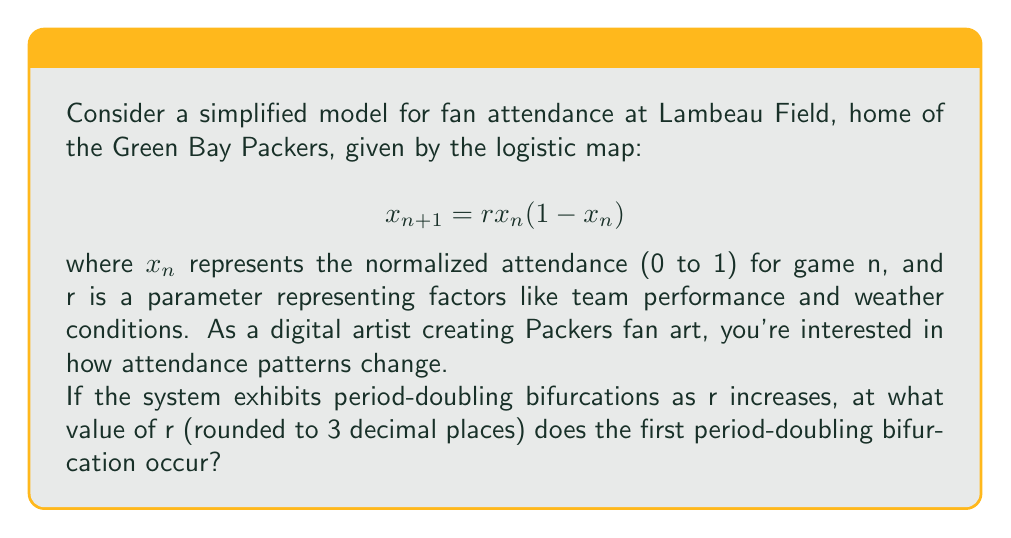What is the answer to this math problem? To find the first period-doubling bifurcation in the logistic map, we need to follow these steps:

1) In a period-1 regime, the system has a fixed point $x^*$ where $x^* = rx^*(1-x^*)$.

2) Solving this equation:
   $$x^* = rx^*(1-x^*)$$
   $$x^* = rx^* - rx^{*2}$$
   $$rx^{*2} - (r-1)x^* = 0$$
   $$x^*(rx^* - (r-1)) = 0$$

   The non-zero solution is $x^* = 1 - \frac{1}{r}$ for $r > 1$.

3) The stability of this fixed point changes when its derivative equals -1:
   $$\left.\frac{d}{dx}(rx(1-x))\right|_{x=x^*} = -1$$

4) Evaluating this derivative:
   $$r(1-2x^*) = -1$$
   $$r(1-2(1-\frac{1}{r})) = -1$$
   $$r(1-2+\frac{2}{r}) = -1$$
   $$r(-1+\frac{2}{r}) = -1$$
   $$-r+2 = -1$$
   $$r = 3$$

5) Therefore, the first period-doubling bifurcation occurs at $r = 3$.

Rounding to 3 decimal places gives 3.000.
Answer: 3.000 